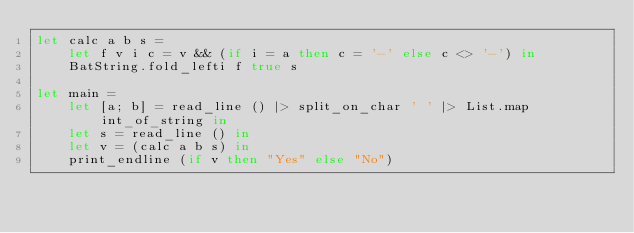Convert code to text. <code><loc_0><loc_0><loc_500><loc_500><_OCaml_>let calc a b s =
    let f v i c = v && (if i = a then c = '-' else c <> '-') in
    BatString.fold_lefti f true s

let main =
    let [a; b] = read_line () |> split_on_char ' ' |> List.map int_of_string in
    let s = read_line () in
    let v = (calc a b s) in
    print_endline (if v then "Yes" else "No")
</code> 